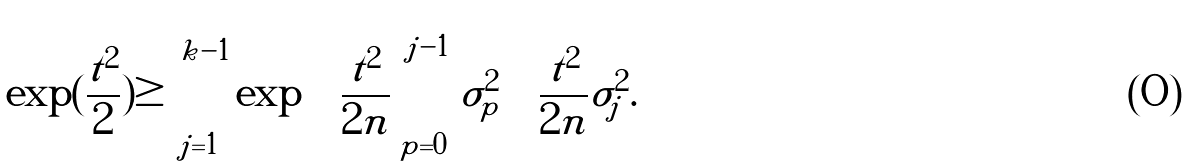<formula> <loc_0><loc_0><loc_500><loc_500>\, \exp ( \frac { t ^ { 2 } } { 2 } ) \geq \sum _ { j = 1 } ^ { k - 1 } \exp \left ( \frac { t ^ { 2 } } { 2 n } \sum _ { p = 0 } ^ { j - 1 } \sigma _ { p } ^ { 2 } \right ) \frac { t ^ { 2 } } { 2 n } \sigma _ { j } ^ { 2 } .</formula> 